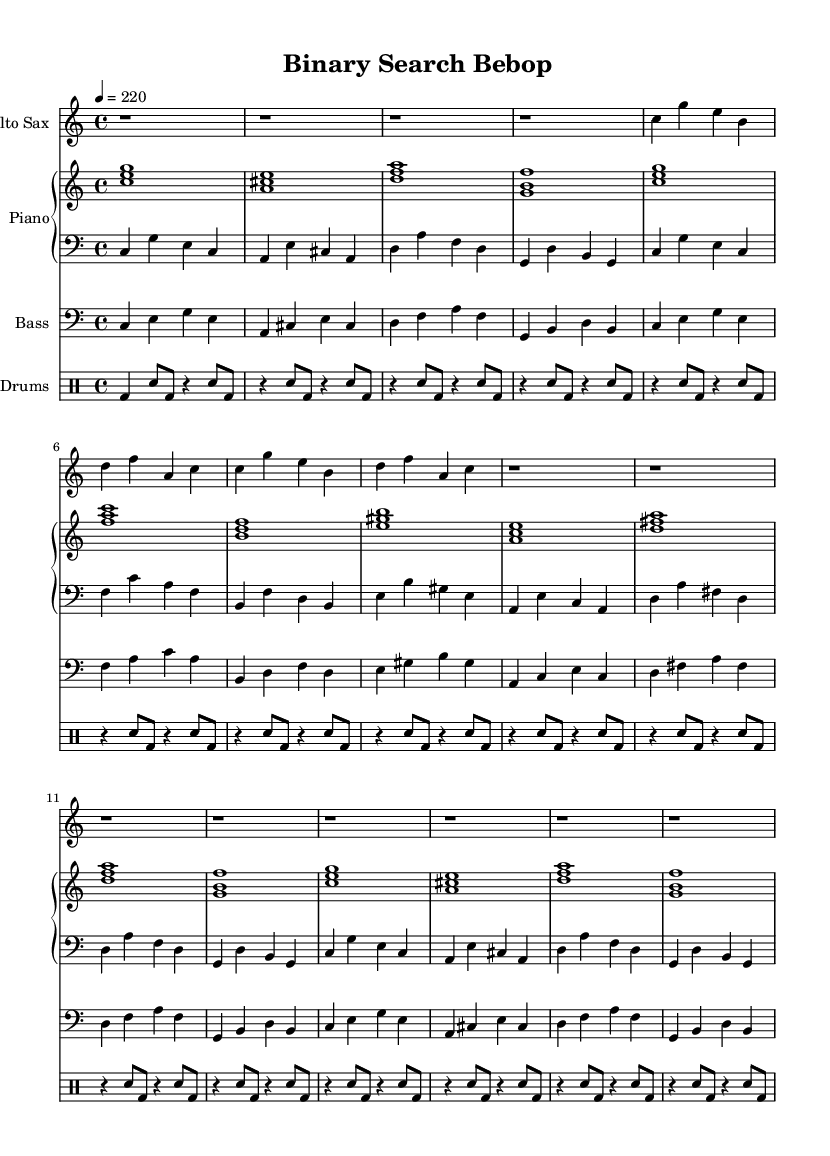What is the key signature of this music? The key signature is C major, which has no sharps or flats.
Answer: C major What is the time signature of this piece? The time signature displayed in the music is 4/4, meaning there are four beats in each measure.
Answer: 4/4 What is the tempo marking for the piece? The tempo marking indicates a speed of 220 beats per minute, which is quite fast and energetic for jazz.
Answer: 220 How many measures are in the saxophone part? By counting the distinct groupings of notes between the bar lines, there are 12 measures in the saxophone part.
Answer: 12 Identify one instrument that plays chords. The piano part features chords played in the right hand, which provide harmonic support to the melody.
Answer: Piano What sections can be identified in the score? The score includes distinct sections for saxophone, piano (right and left hands), bass, and drums, indicative of a standard jazz ensemble format.
Answer: Sections are saxophone, piano, bass, drums What rhythmic pattern is predominantly used in the drums? The drum part primarily utilizes a pattern of bass drum and snare hits, creating a swing feel typical of bebop jazz rhythms.
Answer: Bass and snare pattern 